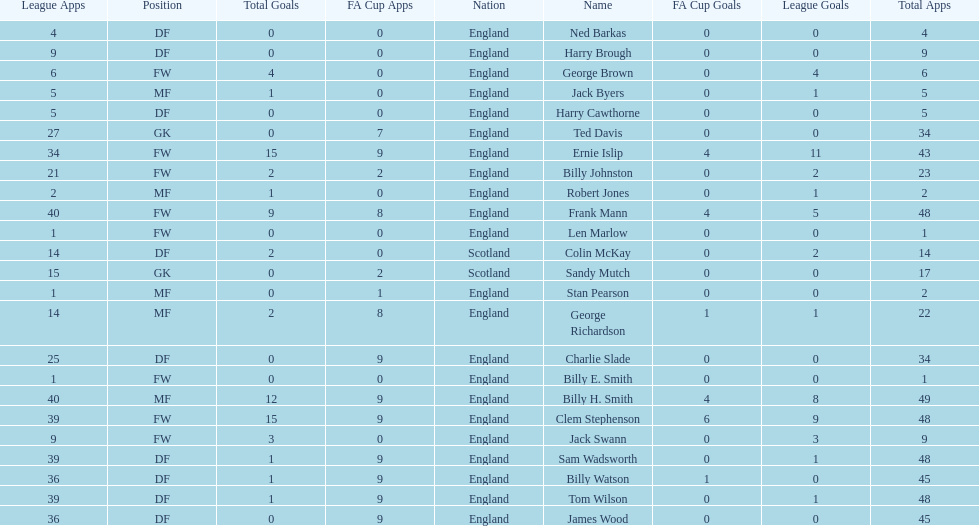Give me the full table as a dictionary. {'header': ['League Apps', 'Position', 'Total Goals', 'FA Cup Apps', 'Nation', 'Name', 'FA Cup Goals', 'League Goals', 'Total Apps'], 'rows': [['4', 'DF', '0', '0', 'England', 'Ned Barkas', '0', '0', '4'], ['9', 'DF', '0', '0', 'England', 'Harry Brough', '0', '0', '9'], ['6', 'FW', '4', '0', 'England', 'George Brown', '0', '4', '6'], ['5', 'MF', '1', '0', 'England', 'Jack Byers', '0', '1', '5'], ['5', 'DF', '0', '0', 'England', 'Harry Cawthorne', '0', '0', '5'], ['27', 'GK', '0', '7', 'England', 'Ted Davis', '0', '0', '34'], ['34', 'FW', '15', '9', 'England', 'Ernie Islip', '4', '11', '43'], ['21', 'FW', '2', '2', 'England', 'Billy Johnston', '0', '2', '23'], ['2', 'MF', '1', '0', 'England', 'Robert Jones', '0', '1', '2'], ['40', 'FW', '9', '8', 'England', 'Frank Mann', '4', '5', '48'], ['1', 'FW', '0', '0', 'England', 'Len Marlow', '0', '0', '1'], ['14', 'DF', '2', '0', 'Scotland', 'Colin McKay', '0', '2', '14'], ['15', 'GK', '0', '2', 'Scotland', 'Sandy Mutch', '0', '0', '17'], ['1', 'MF', '0', '1', 'England', 'Stan Pearson', '0', '0', '2'], ['14', 'MF', '2', '8', 'England', 'George Richardson', '1', '1', '22'], ['25', 'DF', '0', '9', 'England', 'Charlie Slade', '0', '0', '34'], ['1', 'FW', '0', '0', 'England', 'Billy E. Smith', '0', '0', '1'], ['40', 'MF', '12', '9', 'England', 'Billy H. Smith', '4', '8', '49'], ['39', 'FW', '15', '9', 'England', 'Clem Stephenson', '6', '9', '48'], ['9', 'FW', '3', '0', 'England', 'Jack Swann', '0', '3', '9'], ['39', 'DF', '1', '9', 'England', 'Sam Wadsworth', '0', '1', '48'], ['36', 'DF', '1', '9', 'England', 'Billy Watson', '1', '0', '45'], ['39', 'DF', '1', '9', 'England', 'Tom Wilson', '0', '1', '48'], ['36', 'DF', '0', '9', 'England', 'James Wood', '0', '0', '45']]} What is the last name listed on this chart? James Wood. 